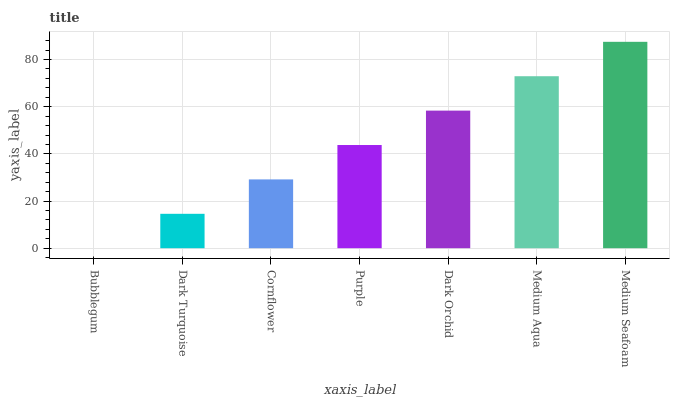Is Dark Turquoise the minimum?
Answer yes or no. No. Is Dark Turquoise the maximum?
Answer yes or no. No. Is Dark Turquoise greater than Bubblegum?
Answer yes or no. Yes. Is Bubblegum less than Dark Turquoise?
Answer yes or no. Yes. Is Bubblegum greater than Dark Turquoise?
Answer yes or no. No. Is Dark Turquoise less than Bubblegum?
Answer yes or no. No. Is Purple the high median?
Answer yes or no. Yes. Is Purple the low median?
Answer yes or no. Yes. Is Cornflower the high median?
Answer yes or no. No. Is Dark Orchid the low median?
Answer yes or no. No. 